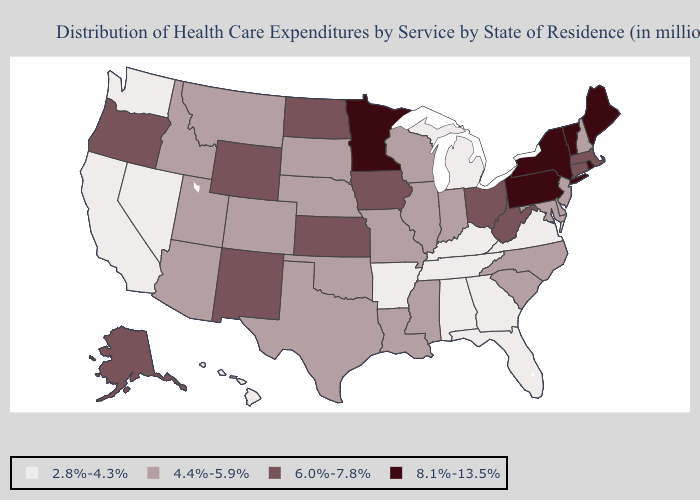What is the value of Missouri?
Short answer required. 4.4%-5.9%. Among the states that border Kansas , which have the lowest value?
Keep it brief. Colorado, Missouri, Nebraska, Oklahoma. What is the value of North Dakota?
Answer briefly. 6.0%-7.8%. Among the states that border Wisconsin , which have the lowest value?
Short answer required. Michigan. Does Indiana have the same value as Alaska?
Short answer required. No. What is the lowest value in the USA?
Write a very short answer. 2.8%-4.3%. Which states have the highest value in the USA?
Answer briefly. Maine, Minnesota, New York, Pennsylvania, Rhode Island, Vermont. What is the value of New York?
Keep it brief. 8.1%-13.5%. Does Connecticut have a lower value than Arizona?
Answer briefly. No. Among the states that border Pennsylvania , does Delaware have the lowest value?
Write a very short answer. Yes. Name the states that have a value in the range 4.4%-5.9%?
Answer briefly. Arizona, Colorado, Delaware, Idaho, Illinois, Indiana, Louisiana, Maryland, Mississippi, Missouri, Montana, Nebraska, New Hampshire, New Jersey, North Carolina, Oklahoma, South Carolina, South Dakota, Texas, Utah, Wisconsin. What is the value of Massachusetts?
Concise answer only. 6.0%-7.8%. Which states have the lowest value in the Northeast?
Be succinct. New Hampshire, New Jersey. Does South Dakota have the lowest value in the USA?
Write a very short answer. No. Does Connecticut have a lower value than New York?
Concise answer only. Yes. 